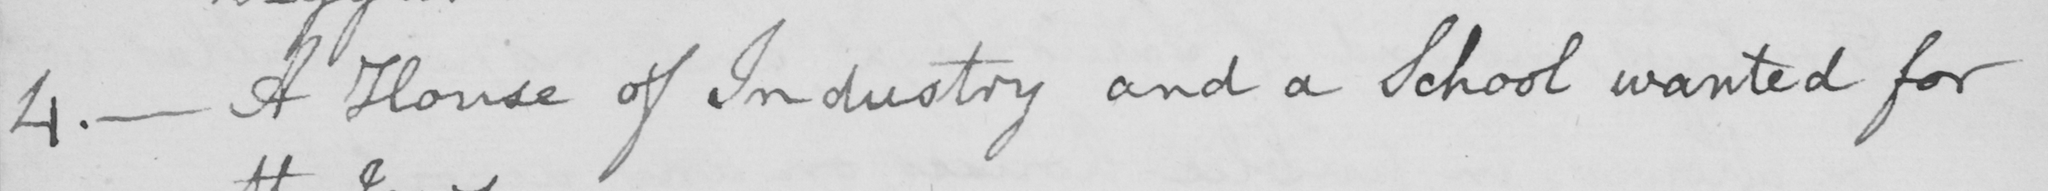Transcribe the text shown in this historical manuscript line. 4 .  _  A House of Industry and a School wanted for 